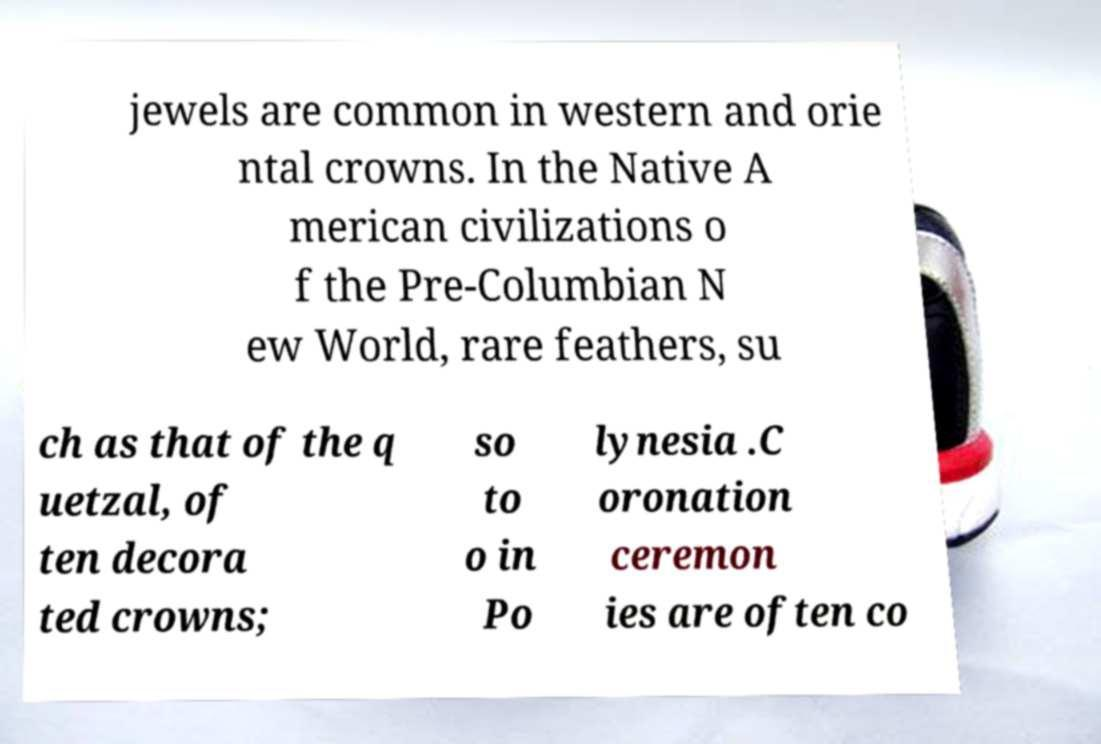There's text embedded in this image that I need extracted. Can you transcribe it verbatim? jewels are common in western and orie ntal crowns. In the Native A merican civilizations o f the Pre-Columbian N ew World, rare feathers, su ch as that of the q uetzal, of ten decora ted crowns; so to o in Po lynesia .C oronation ceremon ies are often co 